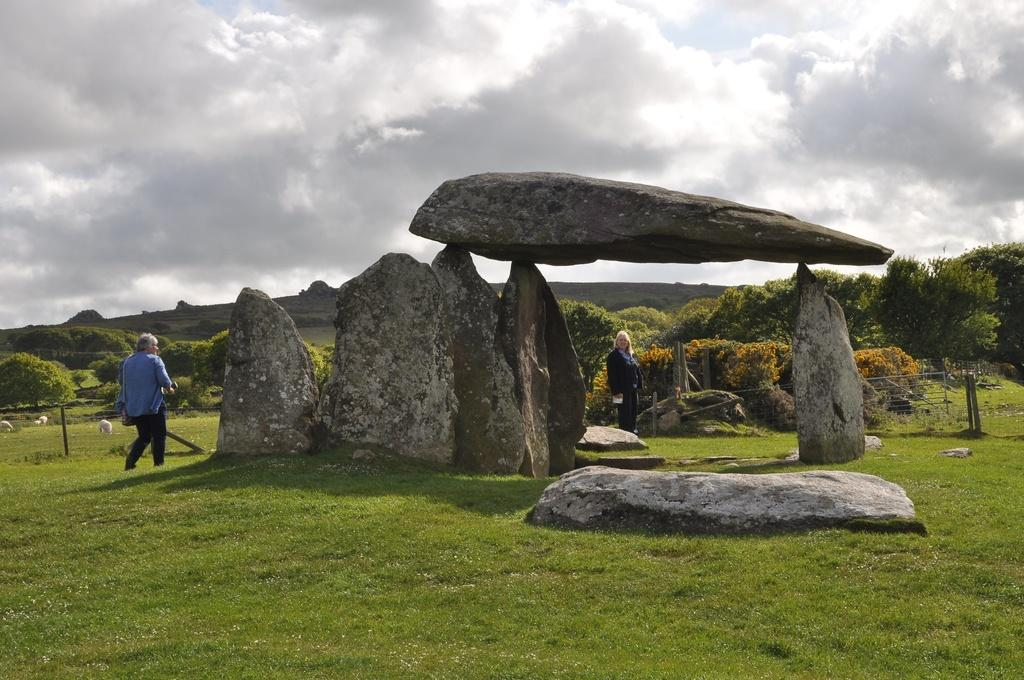What is the name of the image? The image is called "Pentre Ifan". What can be seen in the foreground of the image? There are two people standing on the grass in the foreground. What is located behind the people? There is a fence behind the people. What type of living organisms are present in the image? Animals are present in the image. What other natural elements can be seen in the image? Trees are visible in the image. What is the landscape feature in the background of the image? There is a hill in the background. What part of the natural environment is visible in the image? The sky is visible in the image. How many accounts does the person on the left have in the image? There is no information about accounts in the image; it features a landscape with people, animals, and a hill. What type of oil can be seen dripping from the trees in the image? There is no oil present in the image; it features a landscape with trees, a hill, and people. 